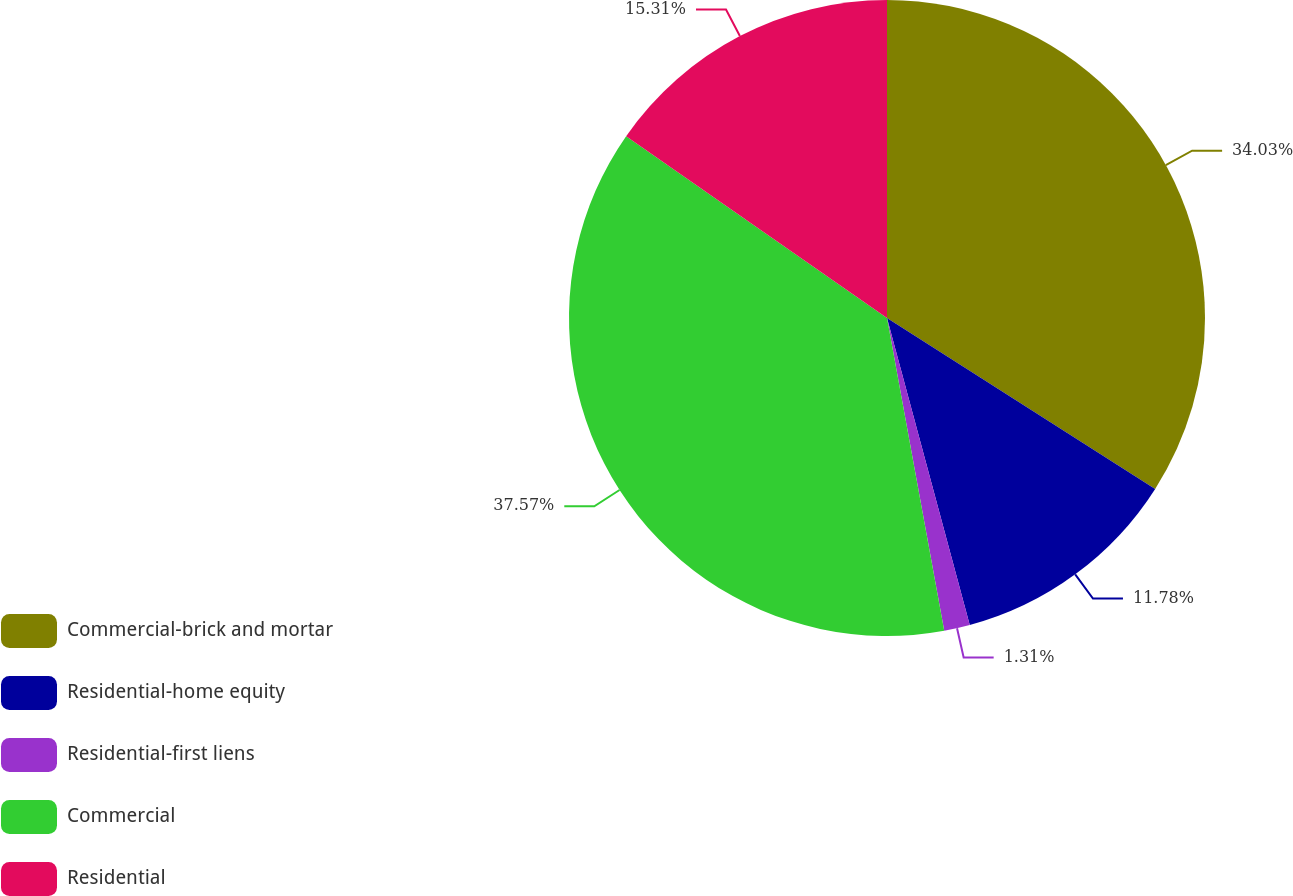Convert chart to OTSL. <chart><loc_0><loc_0><loc_500><loc_500><pie_chart><fcel>Commercial-brick and mortar<fcel>Residential-home equity<fcel>Residential-first liens<fcel>Commercial<fcel>Residential<nl><fcel>34.03%<fcel>11.78%<fcel>1.31%<fcel>37.57%<fcel>15.31%<nl></chart> 